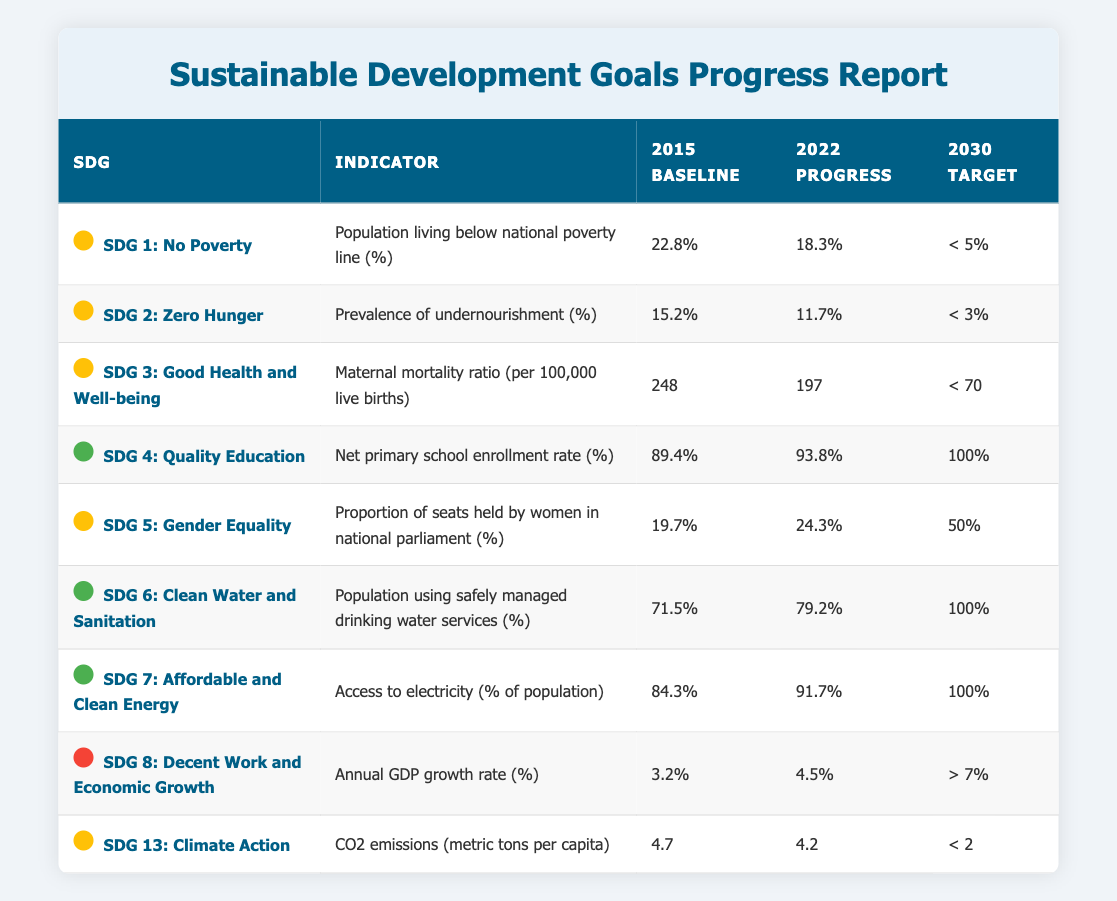What was the baseline percentage for the population living below the national poverty line in 2015? The table shows that the baseline percentage for the population living below the national poverty line in 2015 was 22.8%.
Answer: 22.8% Which Sustainable Development Goal shows the highest percentage for the 2022 progress column? By examining the 2022 progress column, SDG 4: Quality Education shows the highest percentage with 93.8%.
Answer: SDG 4: Quality Education Is the proportion of seats held by women in national parliament in 2022 greater than the 2015 baseline? The table indicates that in 2022, the proportion of seats held by women in national parliament is 24.3%, which is greater than the 2015 baseline of 19.7%.
Answer: Yes What is the difference in the prevalence of undernourishment from 2015 to 2022? The prevalence of undernourishment in 2015 was 15.2%, and in 2022 it is 11.7%. The difference is 15.2% - 11.7% = 3.5%.
Answer: 3.5% If the annual GDP growth rate in 2030 is targeted to be greater than 7%, what is needed to achieve this based on the 2022 progress? The 2022 progress shows an annual GDP growth rate of 4.5%, which is below the targeted 7%. To achieve this target, the growth rate must increase by at least 2.6 percentage points.
Answer: Increase by 2.6 percentage points How many SDGs listed are currently on track to meet their 2030 targets? By examining the table, SDGs 4, 6, and 7 are on track, totaling three SDGs that are currently meeting their 2030 targets.
Answer: Three SDGs Is the target for CO2 emissions in 2030 achievable based on the current progress outlined in the table? The 2022 progress shows CO2 emissions at 4.2 metric tons per capita, but the 2030 target is below 2. Thus, significant reduction is required to meet the target, indicating it is not achievable without major changes.
Answer: No What was the percentage increase in access to electricity from the baseline in 2015 to the progress in 2022? The access to electricity in 2015 was 84.3%, and in 2022, it is 91.7%. The percentage increase is (91.7 - 84.3)/84.3 * 100 = 5.8%.
Answer: 5.8% 